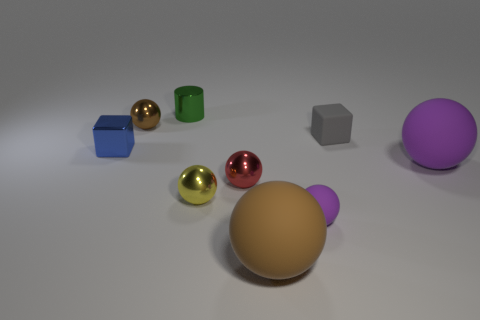Is the shape of the tiny yellow thing the same as the brown thing in front of the tiny blue cube?
Provide a succinct answer. Yes. How many other objects are the same material as the small purple sphere?
Provide a short and direct response. 3. Are there any small things to the left of the small brown shiny thing?
Offer a very short reply. Yes. There is a metal cylinder; is its size the same as the brown ball that is behind the small purple rubber object?
Your response must be concise. Yes. There is a large matte sphere that is right of the brown thing in front of the brown metal sphere; what color is it?
Provide a succinct answer. Purple. Do the rubber cube and the green metallic object have the same size?
Give a very brief answer. Yes. There is a tiny thing that is both in front of the blue metallic object and to the right of the big brown rubber ball; what is its color?
Give a very brief answer. Purple. What is the size of the cylinder?
Your answer should be compact. Small. Does the large matte object that is behind the red object have the same color as the tiny rubber ball?
Provide a short and direct response. Yes. Are there more tiny balls that are behind the metal cube than blue cubes behind the tiny brown ball?
Provide a succinct answer. Yes. 